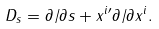<formula> <loc_0><loc_0><loc_500><loc_500>D _ { s } = \partial / \partial s + x ^ { i \prime } \partial / \partial x ^ { i } .</formula> 